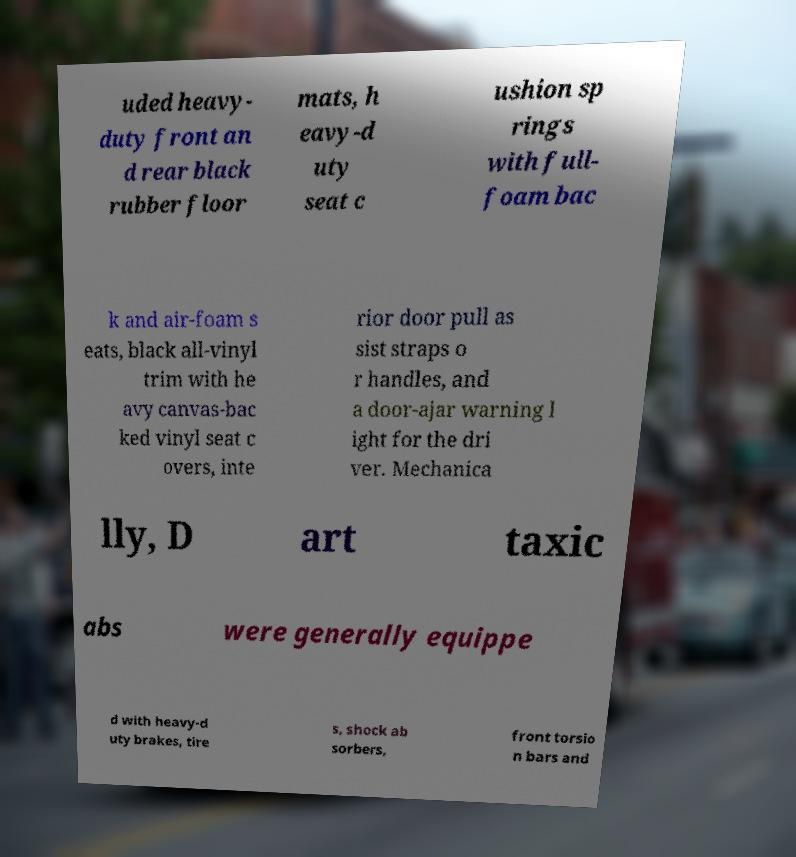Can you read and provide the text displayed in the image?This photo seems to have some interesting text. Can you extract and type it out for me? uded heavy- duty front an d rear black rubber floor mats, h eavy-d uty seat c ushion sp rings with full- foam bac k and air-foam s eats, black all-vinyl trim with he avy canvas-bac ked vinyl seat c overs, inte rior door pull as sist straps o r handles, and a door-ajar warning l ight for the dri ver. Mechanica lly, D art taxic abs were generally equippe d with heavy-d uty brakes, tire s, shock ab sorbers, front torsio n bars and 